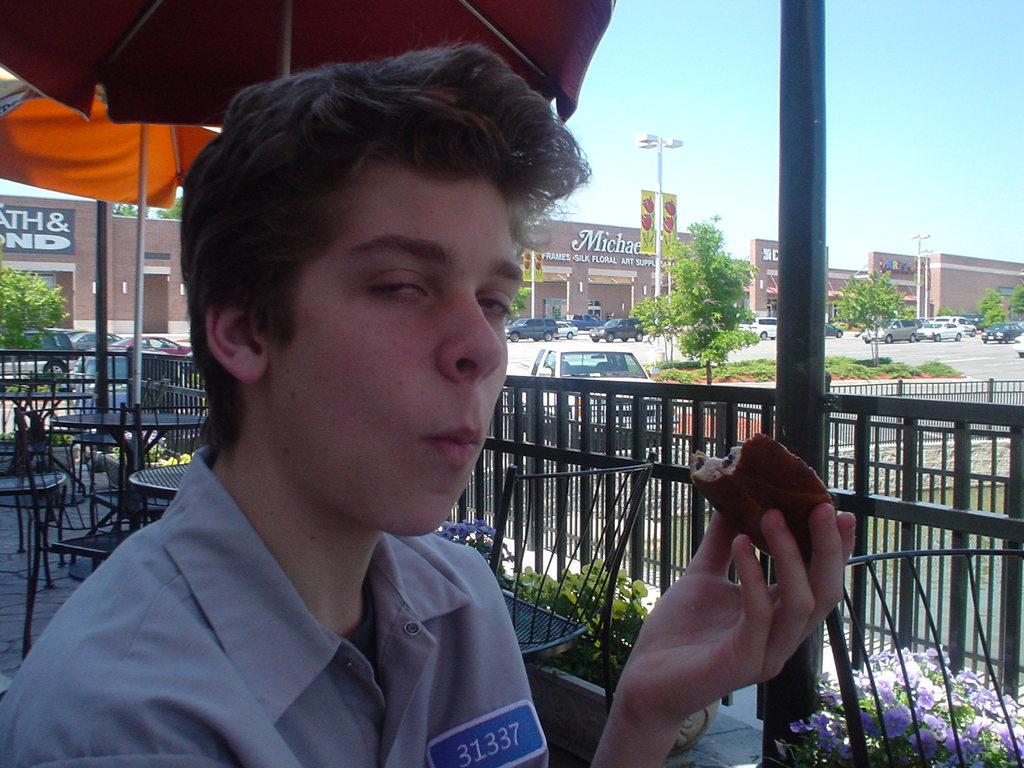What number is on his nametag?
Your answer should be very brief. 31337. What is the name on the building behind?
Make the answer very short. Michaels. 